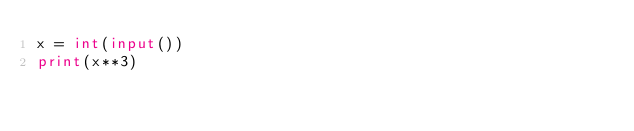Convert code to text. <code><loc_0><loc_0><loc_500><loc_500><_Python_>x = int(input())
print(x**3)
</code> 